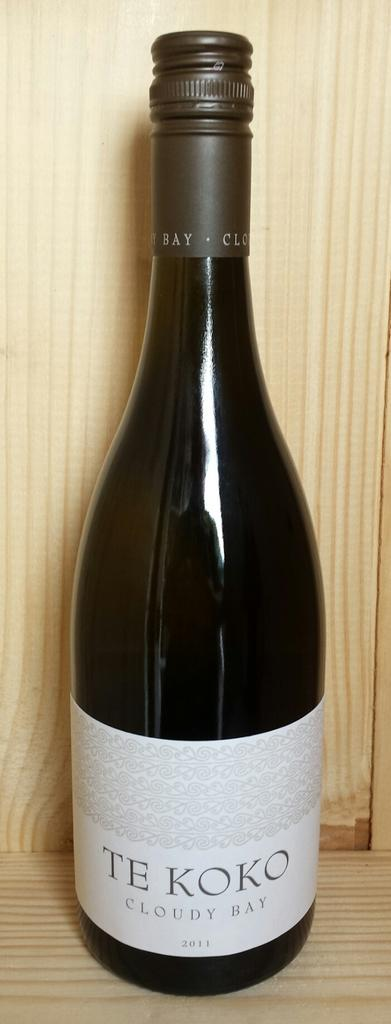Provide a one-sentence caption for the provided image. a bottle of TE KOKO cloudy bay wine. 